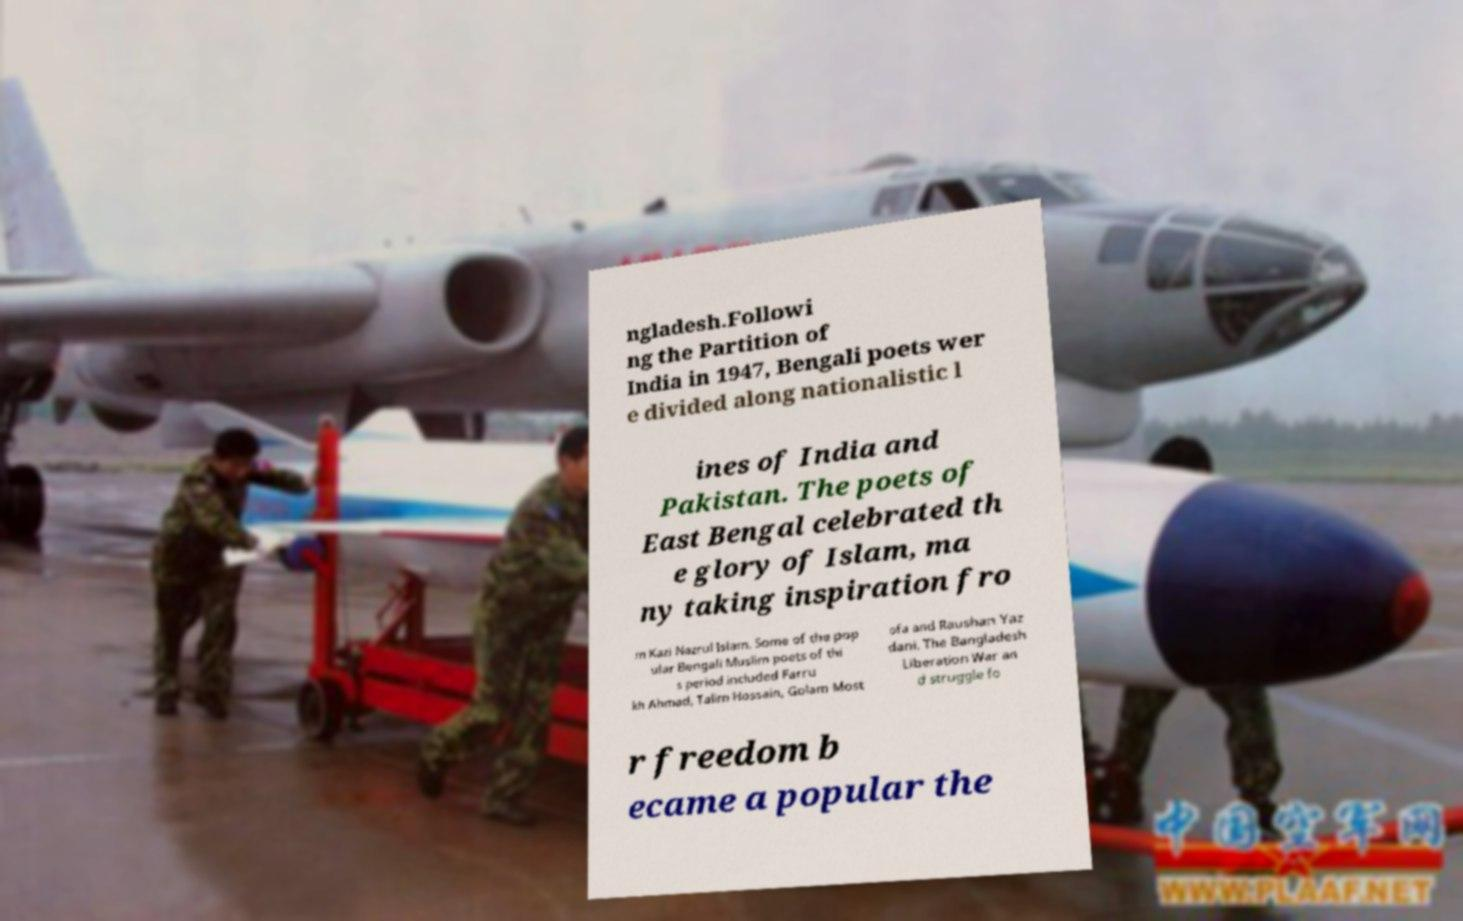There's text embedded in this image that I need extracted. Can you transcribe it verbatim? ngladesh.Followi ng the Partition of India in 1947, Bengali poets wer e divided along nationalistic l ines of India and Pakistan. The poets of East Bengal celebrated th e glory of Islam, ma ny taking inspiration fro m Kazi Nazrul Islam. Some of the pop ular Bengali Muslim poets of thi s period included Farru kh Ahmad, Talim Hossain, Golam Most ofa and Raushan Yaz dani. The Bangladesh Liberation War an d struggle fo r freedom b ecame a popular the 